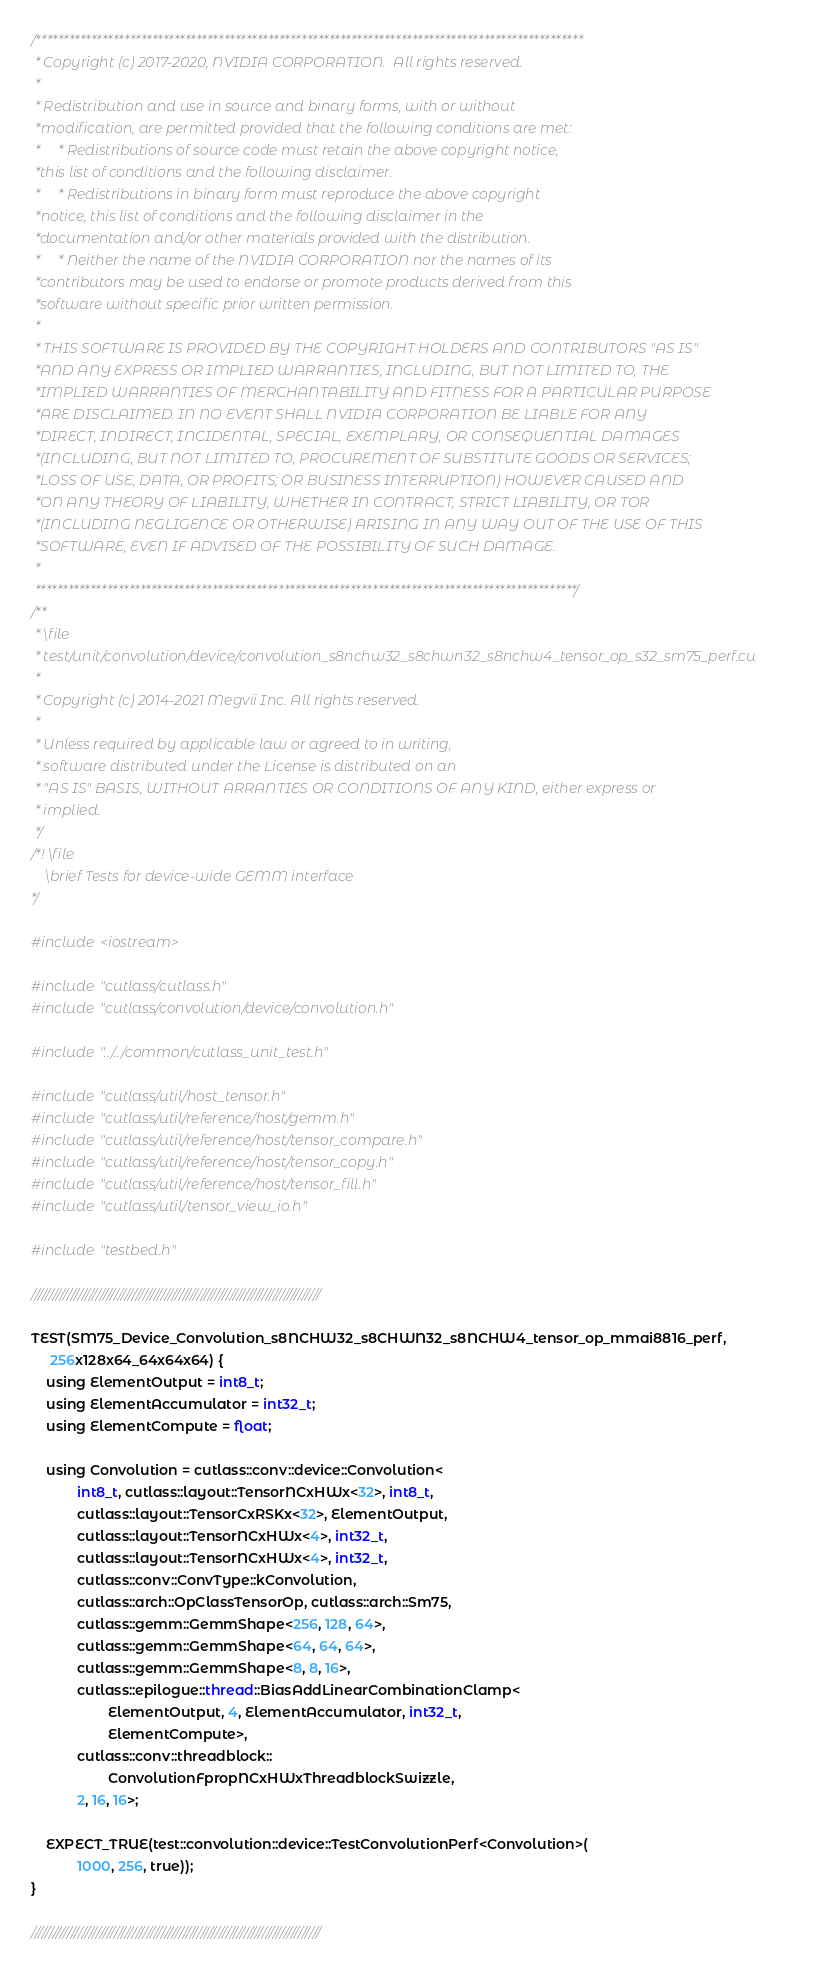<code> <loc_0><loc_0><loc_500><loc_500><_Cuda_>/***************************************************************************************************
 * Copyright (c) 2017-2020, NVIDIA CORPORATION.  All rights reserved.
 *
 * Redistribution and use in source and binary forms, with or without
 *modification, are permitted provided that the following conditions are met:
 *     * Redistributions of source code must retain the above copyright notice,
 *this list of conditions and the following disclaimer.
 *     * Redistributions in binary form must reproduce the above copyright
 *notice, this list of conditions and the following disclaimer in the
 *documentation and/or other materials provided with the distribution.
 *     * Neither the name of the NVIDIA CORPORATION nor the names of its
 *contributors may be used to endorse or promote products derived from this
 *software without specific prior written permission.
 *
 * THIS SOFTWARE IS PROVIDED BY THE COPYRIGHT HOLDERS AND CONTRIBUTORS "AS IS"
 *AND ANY EXPRESS OR IMPLIED WARRANTIES, INCLUDING, BUT NOT LIMITED TO, THE
 *IMPLIED WARRANTIES OF MERCHANTABILITY AND FITNESS FOR A PARTICULAR PURPOSE
 *ARE DISCLAIMED. IN NO EVENT SHALL NVIDIA CORPORATION BE LIABLE FOR ANY
 *DIRECT, INDIRECT, INCIDENTAL, SPECIAL, EXEMPLARY, OR CONSEQUENTIAL DAMAGES
 *(INCLUDING, BUT NOT LIMITED TO, PROCUREMENT OF SUBSTITUTE GOODS OR SERVICES;
 *LOSS OF USE, DATA, OR PROFITS; OR BUSINESS INTERRUPTION) HOWEVER CAUSED AND
 *ON ANY THEORY OF LIABILITY, WHETHER IN CONTRACT, STRICT LIABILITY, OR TOR
 *(INCLUDING NEGLIGENCE OR OTHERWISE) ARISING IN ANY WAY OUT OF THE USE OF THIS
 *SOFTWARE, EVEN IF ADVISED OF THE POSSIBILITY OF SUCH DAMAGE.
 *
 **************************************************************************************************/
/**
 * \file
 * test/unit/convolution/device/convolution_s8nchw32_s8chwn32_s8nchw4_tensor_op_s32_sm75_perf.cu
 *
 * Copyright (c) 2014-2021 Megvii Inc. All rights reserved.
 *
 * Unless required by applicable law or agreed to in writing,
 * software distributed under the License is distributed on an
 * "AS IS" BASIS, WITHOUT ARRANTIES OR CONDITIONS OF ANY KIND, either express or
 * implied.
 */
/*! \file
    \brief Tests for device-wide GEMM interface
*/

#include <iostream>

#include "cutlass/cutlass.h"
#include "cutlass/convolution/device/convolution.h"

#include "../../common/cutlass_unit_test.h"

#include "cutlass/util/host_tensor.h"
#include "cutlass/util/reference/host/gemm.h"
#include "cutlass/util/reference/host/tensor_compare.h"
#include "cutlass/util/reference/host/tensor_copy.h"
#include "cutlass/util/reference/host/tensor_fill.h"
#include "cutlass/util/tensor_view_io.h"

#include "testbed.h"

////////////////////////////////////////////////////////////////////////////////

TEST(SM75_Device_Convolution_s8NCHW32_s8CHWN32_s8NCHW4_tensor_op_mmai8816_perf,
     256x128x64_64x64x64) {
    using ElementOutput = int8_t;
    using ElementAccumulator = int32_t;
    using ElementCompute = float;

    using Convolution = cutlass::conv::device::Convolution<
            int8_t, cutlass::layout::TensorNCxHWx<32>, int8_t,
            cutlass::layout::TensorCxRSKx<32>, ElementOutput,
            cutlass::layout::TensorNCxHWx<4>, int32_t,
            cutlass::layout::TensorNCxHWx<4>, int32_t,
            cutlass::conv::ConvType::kConvolution,
            cutlass::arch::OpClassTensorOp, cutlass::arch::Sm75,
            cutlass::gemm::GemmShape<256, 128, 64>,
            cutlass::gemm::GemmShape<64, 64, 64>,
            cutlass::gemm::GemmShape<8, 8, 16>,
            cutlass::epilogue::thread::BiasAddLinearCombinationClamp<
                    ElementOutput, 4, ElementAccumulator, int32_t,
                    ElementCompute>,
            cutlass::conv::threadblock::
                    ConvolutionFpropNCxHWxThreadblockSwizzle,
            2, 16, 16>;

    EXPECT_TRUE(test::convolution::device::TestConvolutionPerf<Convolution>(
            1000, 256, true));
}

////////////////////////////////////////////////////////////////////////////////
</code> 